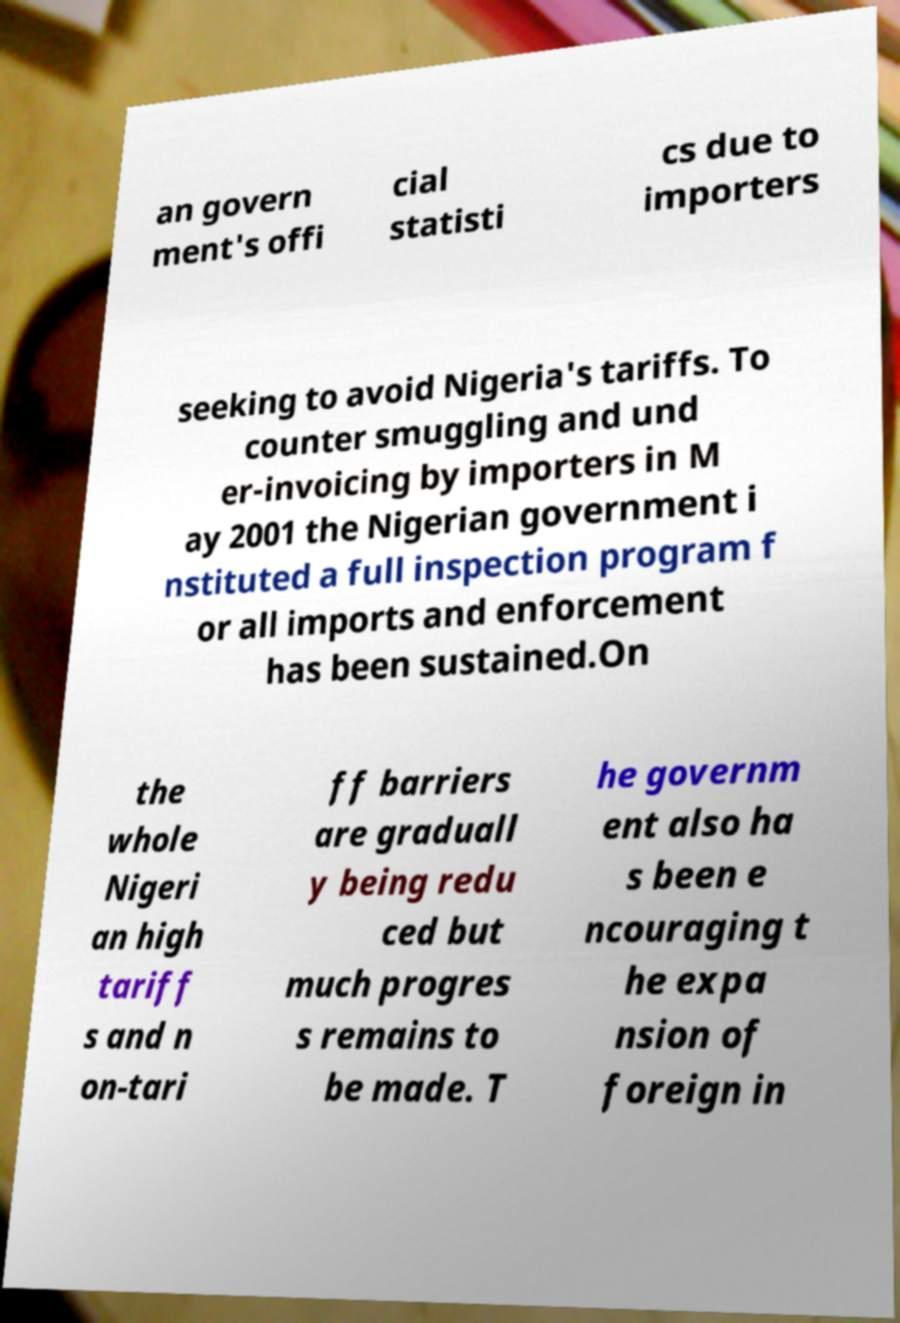Can you read and provide the text displayed in the image?This photo seems to have some interesting text. Can you extract and type it out for me? an govern ment's offi cial statisti cs due to importers seeking to avoid Nigeria's tariffs. To counter smuggling and und er-invoicing by importers in M ay 2001 the Nigerian government i nstituted a full inspection program f or all imports and enforcement has been sustained.On the whole Nigeri an high tariff s and n on-tari ff barriers are graduall y being redu ced but much progres s remains to be made. T he governm ent also ha s been e ncouraging t he expa nsion of foreign in 